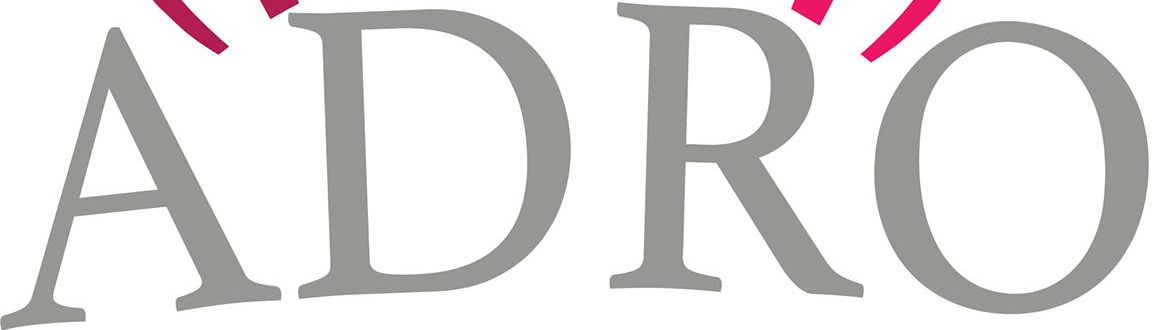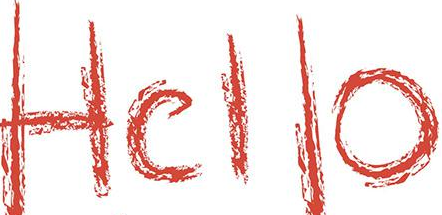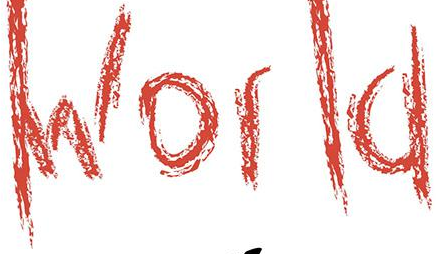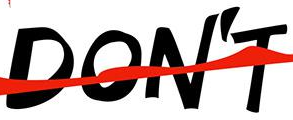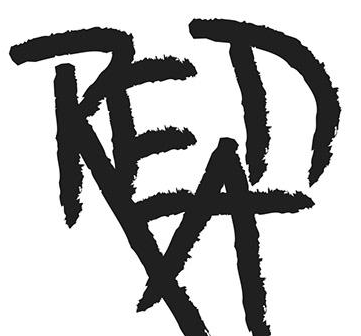What text appears in these images from left to right, separated by a semicolon? ADRO; Hello; World; DON'T; READ 